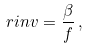Convert formula to latex. <formula><loc_0><loc_0><loc_500><loc_500>\ r i n v = \frac { \beta } { f } \, ,</formula> 